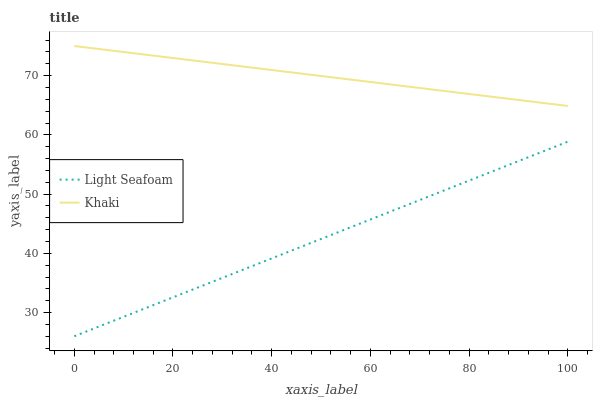Does Khaki have the minimum area under the curve?
Answer yes or no. No. Is Khaki the roughest?
Answer yes or no. No. Does Khaki have the lowest value?
Answer yes or no. No. Is Light Seafoam less than Khaki?
Answer yes or no. Yes. Is Khaki greater than Light Seafoam?
Answer yes or no. Yes. Does Light Seafoam intersect Khaki?
Answer yes or no. No. 